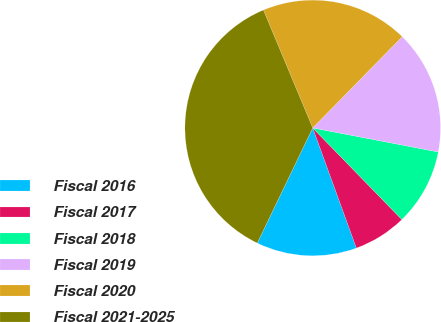<chart> <loc_0><loc_0><loc_500><loc_500><pie_chart><fcel>Fiscal 2016<fcel>Fiscal 2017<fcel>Fiscal 2018<fcel>Fiscal 2019<fcel>Fiscal 2020<fcel>Fiscal 2021-2025<nl><fcel>12.69%<fcel>6.73%<fcel>9.71%<fcel>15.67%<fcel>18.65%<fcel>36.55%<nl></chart> 